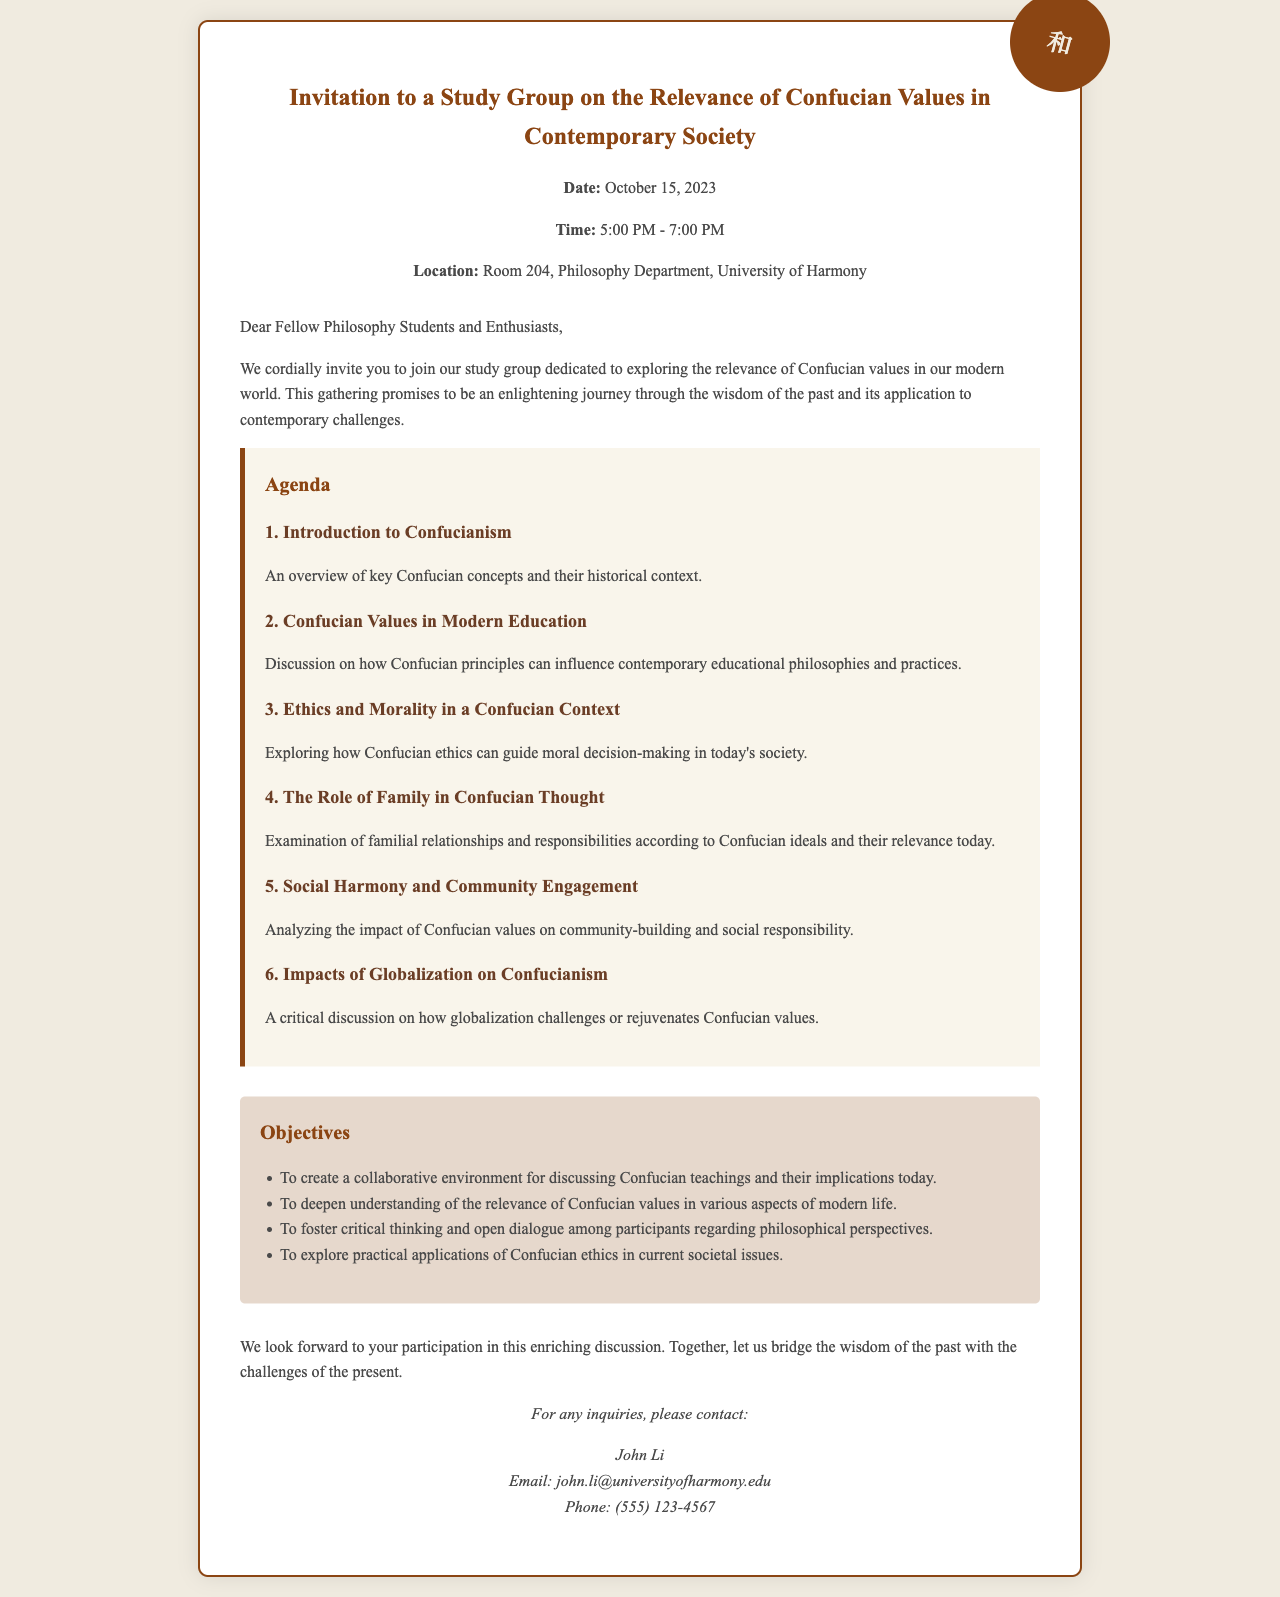What is the date of the study group? The date of the study group is specifically mentioned in the document.
Answer: October 15, 2023 What time does the study group start? The time is provided in the document, indicating when the event commences.
Answer: 5:00 PM What is the location of the study group? The location of the event is explicitly stated in the letter.
Answer: Room 204, Philosophy Department, University of Harmony Who is the contact person for inquiries? The document states a specific individual to contact for further questions.
Answer: John Li What is one agenda item for the study group? An agenda item is listed in the document outlining topics for discussion.
Answer: Introduction to Confucianism What is one objective of the study group? The objectives of the group are outlined, each aiming for a specific goal.
Answer: To create a collaborative environment for discussing Confucian teachings and their implications today What is the total number of agenda items listed? The document lists all topics in the agenda section.
Answer: 6 What philosophical tradition is the focus of the study group? The document makes clear the philosophical tradition being discussed.
Answer: Confucianism What style of gathering is the event described as? The tone of the invitation implies the nature of the gathering.
Answer: Collaborative 